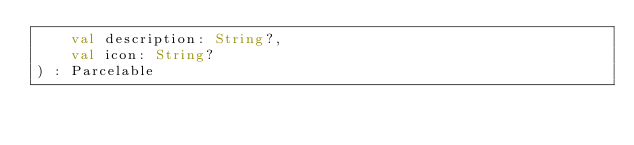<code> <loc_0><loc_0><loc_500><loc_500><_Kotlin_>    val description: String?,
    val icon: String?
) : Parcelable
</code> 